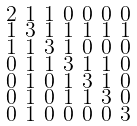<formula> <loc_0><loc_0><loc_500><loc_500>\begin{smallmatrix} 2 & 1 & 1 & 0 & 0 & 0 & 0 \\ 1 & 3 & 1 & 1 & 1 & 1 & 1 \\ 1 & 1 & 3 & 1 & 0 & 0 & 0 \\ 0 & 1 & 1 & 3 & 1 & 1 & 0 \\ 0 & 1 & 0 & 1 & 3 & 1 & 0 \\ 0 & 1 & 0 & 1 & 1 & 3 & 0 \\ 0 & 1 & 0 & 0 & 0 & 0 & 3 \end{smallmatrix}</formula> 